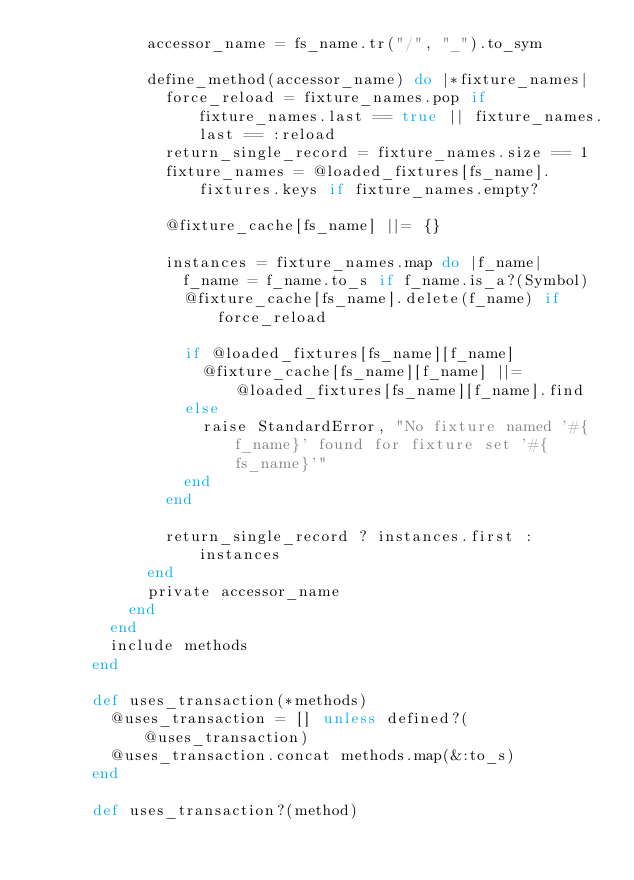<code> <loc_0><loc_0><loc_500><loc_500><_Ruby_>            accessor_name = fs_name.tr("/", "_").to_sym

            define_method(accessor_name) do |*fixture_names|
              force_reload = fixture_names.pop if fixture_names.last == true || fixture_names.last == :reload
              return_single_record = fixture_names.size == 1
              fixture_names = @loaded_fixtures[fs_name].fixtures.keys if fixture_names.empty?

              @fixture_cache[fs_name] ||= {}

              instances = fixture_names.map do |f_name|
                f_name = f_name.to_s if f_name.is_a?(Symbol)
                @fixture_cache[fs_name].delete(f_name) if force_reload

                if @loaded_fixtures[fs_name][f_name]
                  @fixture_cache[fs_name][f_name] ||= @loaded_fixtures[fs_name][f_name].find
                else
                  raise StandardError, "No fixture named '#{f_name}' found for fixture set '#{fs_name}'"
                end
              end

              return_single_record ? instances.first : instances
            end
            private accessor_name
          end
        end
        include methods
      end

      def uses_transaction(*methods)
        @uses_transaction = [] unless defined?(@uses_transaction)
        @uses_transaction.concat methods.map(&:to_s)
      end

      def uses_transaction?(method)</code> 